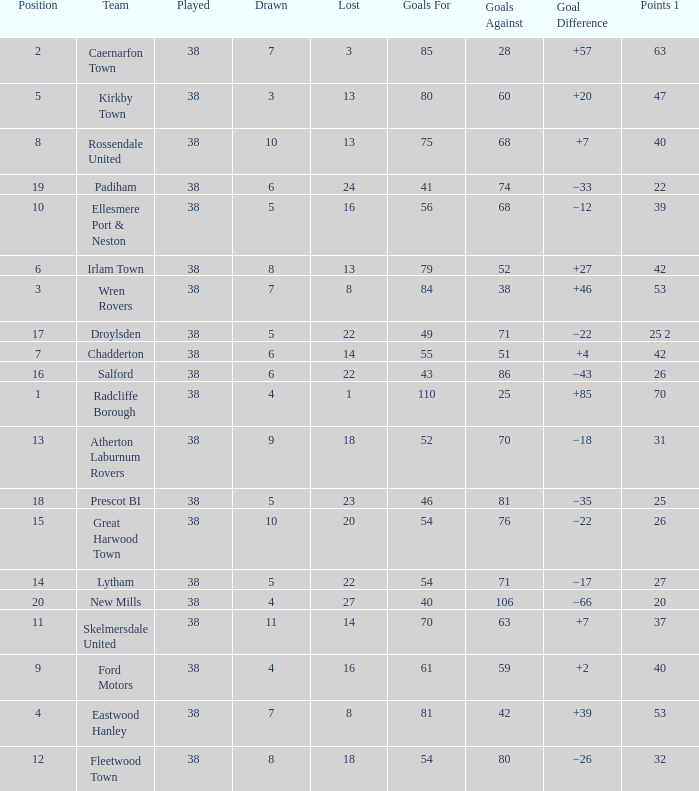How much Drawn has Goals Against of 81, and a Lost larger than 23? 0.0. 